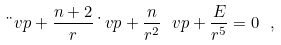<formula> <loc_0><loc_0><loc_500><loc_500>\ddot { \ } v p + \frac { n + 2 } { r } \dot { \ } v p + \frac { n } { r ^ { 2 } } \ v p + \frac { E } { r ^ { 5 } } = 0 \ ,</formula> 